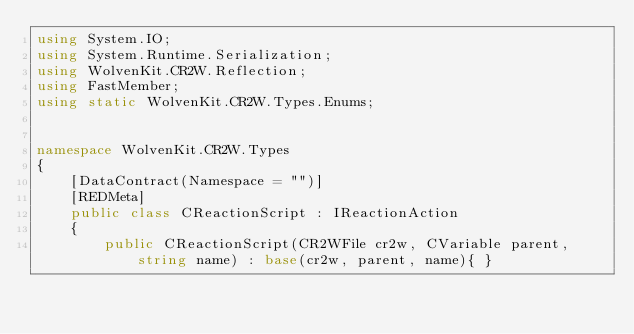Convert code to text. <code><loc_0><loc_0><loc_500><loc_500><_C#_>using System.IO;
using System.Runtime.Serialization;
using WolvenKit.CR2W.Reflection;
using FastMember;
using static WolvenKit.CR2W.Types.Enums;


namespace WolvenKit.CR2W.Types
{
	[DataContract(Namespace = "")]
	[REDMeta]
	public class CReactionScript : IReactionAction
	{
		public CReactionScript(CR2WFile cr2w, CVariable parent, string name) : base(cr2w, parent, name){ }
</code> 